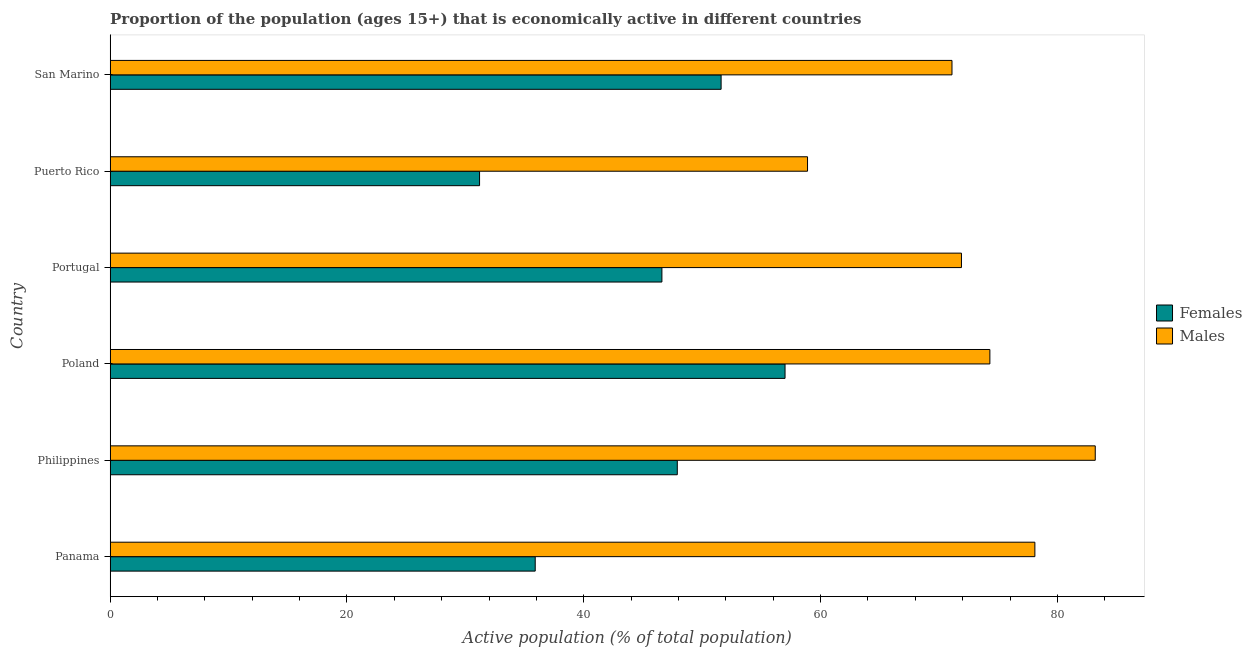Are the number of bars per tick equal to the number of legend labels?
Make the answer very short. Yes. How many bars are there on the 3rd tick from the top?
Your response must be concise. 2. How many bars are there on the 3rd tick from the bottom?
Provide a succinct answer. 2. What is the label of the 1st group of bars from the top?
Keep it short and to the point. San Marino. In how many cases, is the number of bars for a given country not equal to the number of legend labels?
Your answer should be compact. 0. What is the percentage of economically active male population in Portugal?
Keep it short and to the point. 71.9. Across all countries, what is the maximum percentage of economically active female population?
Offer a very short reply. 57. Across all countries, what is the minimum percentage of economically active female population?
Provide a short and direct response. 31.2. In which country was the percentage of economically active male population maximum?
Your answer should be very brief. Philippines. In which country was the percentage of economically active female population minimum?
Your response must be concise. Puerto Rico. What is the total percentage of economically active female population in the graph?
Keep it short and to the point. 270.2. What is the difference between the percentage of economically active male population in Poland and that in Puerto Rico?
Your response must be concise. 15.4. What is the difference between the percentage of economically active male population in San Marino and the percentage of economically active female population in Poland?
Your answer should be compact. 14.1. What is the average percentage of economically active male population per country?
Provide a succinct answer. 72.92. What is the difference between the percentage of economically active female population and percentage of economically active male population in Puerto Rico?
Give a very brief answer. -27.7. In how many countries, is the percentage of economically active male population greater than 60 %?
Your answer should be compact. 5. What is the ratio of the percentage of economically active male population in Panama to that in Puerto Rico?
Ensure brevity in your answer.  1.33. Is the difference between the percentage of economically active female population in Portugal and San Marino greater than the difference between the percentage of economically active male population in Portugal and San Marino?
Give a very brief answer. No. What is the difference between the highest and the second highest percentage of economically active female population?
Offer a very short reply. 5.4. What is the difference between the highest and the lowest percentage of economically active female population?
Provide a short and direct response. 25.8. In how many countries, is the percentage of economically active female population greater than the average percentage of economically active female population taken over all countries?
Give a very brief answer. 4. Is the sum of the percentage of economically active female population in Poland and Portugal greater than the maximum percentage of economically active male population across all countries?
Ensure brevity in your answer.  Yes. What does the 1st bar from the top in San Marino represents?
Offer a terse response. Males. What does the 2nd bar from the bottom in Poland represents?
Your answer should be very brief. Males. How many bars are there?
Ensure brevity in your answer.  12. What is the difference between two consecutive major ticks on the X-axis?
Give a very brief answer. 20. Are the values on the major ticks of X-axis written in scientific E-notation?
Provide a short and direct response. No. Does the graph contain any zero values?
Your answer should be very brief. No. Where does the legend appear in the graph?
Your answer should be compact. Center right. How many legend labels are there?
Offer a terse response. 2. How are the legend labels stacked?
Offer a very short reply. Vertical. What is the title of the graph?
Your answer should be very brief. Proportion of the population (ages 15+) that is economically active in different countries. What is the label or title of the X-axis?
Provide a succinct answer. Active population (% of total population). What is the label or title of the Y-axis?
Your answer should be very brief. Country. What is the Active population (% of total population) in Females in Panama?
Offer a terse response. 35.9. What is the Active population (% of total population) of Males in Panama?
Offer a terse response. 78.1. What is the Active population (% of total population) in Females in Philippines?
Provide a short and direct response. 47.9. What is the Active population (% of total population) in Males in Philippines?
Provide a succinct answer. 83.2. What is the Active population (% of total population) of Females in Poland?
Make the answer very short. 57. What is the Active population (% of total population) of Males in Poland?
Ensure brevity in your answer.  74.3. What is the Active population (% of total population) in Females in Portugal?
Offer a very short reply. 46.6. What is the Active population (% of total population) in Males in Portugal?
Ensure brevity in your answer.  71.9. What is the Active population (% of total population) of Females in Puerto Rico?
Provide a short and direct response. 31.2. What is the Active population (% of total population) in Males in Puerto Rico?
Your answer should be compact. 58.9. What is the Active population (% of total population) in Females in San Marino?
Ensure brevity in your answer.  51.6. What is the Active population (% of total population) in Males in San Marino?
Provide a succinct answer. 71.1. Across all countries, what is the maximum Active population (% of total population) in Males?
Provide a short and direct response. 83.2. Across all countries, what is the minimum Active population (% of total population) of Females?
Provide a short and direct response. 31.2. Across all countries, what is the minimum Active population (% of total population) of Males?
Provide a succinct answer. 58.9. What is the total Active population (% of total population) of Females in the graph?
Keep it short and to the point. 270.2. What is the total Active population (% of total population) in Males in the graph?
Your response must be concise. 437.5. What is the difference between the Active population (% of total population) of Males in Panama and that in Philippines?
Ensure brevity in your answer.  -5.1. What is the difference between the Active population (% of total population) of Females in Panama and that in Poland?
Provide a short and direct response. -21.1. What is the difference between the Active population (% of total population) of Males in Panama and that in Poland?
Provide a short and direct response. 3.8. What is the difference between the Active population (% of total population) of Females in Panama and that in Portugal?
Keep it short and to the point. -10.7. What is the difference between the Active population (% of total population) of Males in Panama and that in Puerto Rico?
Your answer should be compact. 19.2. What is the difference between the Active population (% of total population) of Females in Panama and that in San Marino?
Your answer should be compact. -15.7. What is the difference between the Active population (% of total population) in Males in Panama and that in San Marino?
Make the answer very short. 7. What is the difference between the Active population (% of total population) of Females in Philippines and that in Portugal?
Your answer should be compact. 1.3. What is the difference between the Active population (% of total population) of Males in Philippines and that in Puerto Rico?
Your answer should be very brief. 24.3. What is the difference between the Active population (% of total population) of Females in Philippines and that in San Marino?
Make the answer very short. -3.7. What is the difference between the Active population (% of total population) in Males in Philippines and that in San Marino?
Give a very brief answer. 12.1. What is the difference between the Active population (% of total population) in Females in Poland and that in Portugal?
Make the answer very short. 10.4. What is the difference between the Active population (% of total population) of Males in Poland and that in Portugal?
Ensure brevity in your answer.  2.4. What is the difference between the Active population (% of total population) in Females in Poland and that in Puerto Rico?
Keep it short and to the point. 25.8. What is the difference between the Active population (% of total population) of Males in Poland and that in Puerto Rico?
Offer a very short reply. 15.4. What is the difference between the Active population (% of total population) of Males in Poland and that in San Marino?
Your response must be concise. 3.2. What is the difference between the Active population (% of total population) in Females in Portugal and that in Puerto Rico?
Ensure brevity in your answer.  15.4. What is the difference between the Active population (% of total population) of Males in Portugal and that in Puerto Rico?
Your answer should be compact. 13. What is the difference between the Active population (% of total population) of Males in Portugal and that in San Marino?
Ensure brevity in your answer.  0.8. What is the difference between the Active population (% of total population) of Females in Puerto Rico and that in San Marino?
Your answer should be compact. -20.4. What is the difference between the Active population (% of total population) in Males in Puerto Rico and that in San Marino?
Provide a short and direct response. -12.2. What is the difference between the Active population (% of total population) of Females in Panama and the Active population (% of total population) of Males in Philippines?
Offer a very short reply. -47.3. What is the difference between the Active population (% of total population) in Females in Panama and the Active population (% of total population) in Males in Poland?
Ensure brevity in your answer.  -38.4. What is the difference between the Active population (% of total population) in Females in Panama and the Active population (% of total population) in Males in Portugal?
Offer a terse response. -36. What is the difference between the Active population (% of total population) in Females in Panama and the Active population (% of total population) in Males in San Marino?
Make the answer very short. -35.2. What is the difference between the Active population (% of total population) of Females in Philippines and the Active population (% of total population) of Males in Poland?
Your answer should be very brief. -26.4. What is the difference between the Active population (% of total population) in Females in Philippines and the Active population (% of total population) in Males in Portugal?
Ensure brevity in your answer.  -24. What is the difference between the Active population (% of total population) of Females in Philippines and the Active population (% of total population) of Males in Puerto Rico?
Your answer should be compact. -11. What is the difference between the Active population (% of total population) of Females in Philippines and the Active population (% of total population) of Males in San Marino?
Provide a short and direct response. -23.2. What is the difference between the Active population (% of total population) of Females in Poland and the Active population (% of total population) of Males in Portugal?
Offer a very short reply. -14.9. What is the difference between the Active population (% of total population) in Females in Poland and the Active population (% of total population) in Males in Puerto Rico?
Give a very brief answer. -1.9. What is the difference between the Active population (% of total population) in Females in Poland and the Active population (% of total population) in Males in San Marino?
Keep it short and to the point. -14.1. What is the difference between the Active population (% of total population) in Females in Portugal and the Active population (% of total population) in Males in San Marino?
Offer a very short reply. -24.5. What is the difference between the Active population (% of total population) of Females in Puerto Rico and the Active population (% of total population) of Males in San Marino?
Your answer should be compact. -39.9. What is the average Active population (% of total population) in Females per country?
Provide a succinct answer. 45.03. What is the average Active population (% of total population) of Males per country?
Your answer should be compact. 72.92. What is the difference between the Active population (% of total population) in Females and Active population (% of total population) in Males in Panama?
Ensure brevity in your answer.  -42.2. What is the difference between the Active population (% of total population) of Females and Active population (% of total population) of Males in Philippines?
Offer a very short reply. -35.3. What is the difference between the Active population (% of total population) in Females and Active population (% of total population) in Males in Poland?
Give a very brief answer. -17.3. What is the difference between the Active population (% of total population) of Females and Active population (% of total population) of Males in Portugal?
Provide a short and direct response. -25.3. What is the difference between the Active population (% of total population) of Females and Active population (% of total population) of Males in Puerto Rico?
Offer a very short reply. -27.7. What is the difference between the Active population (% of total population) in Females and Active population (% of total population) in Males in San Marino?
Provide a short and direct response. -19.5. What is the ratio of the Active population (% of total population) in Females in Panama to that in Philippines?
Ensure brevity in your answer.  0.75. What is the ratio of the Active population (% of total population) in Males in Panama to that in Philippines?
Provide a short and direct response. 0.94. What is the ratio of the Active population (% of total population) of Females in Panama to that in Poland?
Your response must be concise. 0.63. What is the ratio of the Active population (% of total population) in Males in Panama to that in Poland?
Provide a short and direct response. 1.05. What is the ratio of the Active population (% of total population) of Females in Panama to that in Portugal?
Your answer should be very brief. 0.77. What is the ratio of the Active population (% of total population) in Males in Panama to that in Portugal?
Your answer should be very brief. 1.09. What is the ratio of the Active population (% of total population) of Females in Panama to that in Puerto Rico?
Keep it short and to the point. 1.15. What is the ratio of the Active population (% of total population) in Males in Panama to that in Puerto Rico?
Provide a succinct answer. 1.33. What is the ratio of the Active population (% of total population) of Females in Panama to that in San Marino?
Give a very brief answer. 0.7. What is the ratio of the Active population (% of total population) of Males in Panama to that in San Marino?
Keep it short and to the point. 1.1. What is the ratio of the Active population (% of total population) of Females in Philippines to that in Poland?
Give a very brief answer. 0.84. What is the ratio of the Active population (% of total population) in Males in Philippines to that in Poland?
Offer a terse response. 1.12. What is the ratio of the Active population (% of total population) of Females in Philippines to that in Portugal?
Keep it short and to the point. 1.03. What is the ratio of the Active population (% of total population) in Males in Philippines to that in Portugal?
Your answer should be compact. 1.16. What is the ratio of the Active population (% of total population) of Females in Philippines to that in Puerto Rico?
Make the answer very short. 1.54. What is the ratio of the Active population (% of total population) of Males in Philippines to that in Puerto Rico?
Provide a succinct answer. 1.41. What is the ratio of the Active population (% of total population) of Females in Philippines to that in San Marino?
Keep it short and to the point. 0.93. What is the ratio of the Active population (% of total population) of Males in Philippines to that in San Marino?
Your answer should be compact. 1.17. What is the ratio of the Active population (% of total population) of Females in Poland to that in Portugal?
Give a very brief answer. 1.22. What is the ratio of the Active population (% of total population) in Males in Poland to that in Portugal?
Keep it short and to the point. 1.03. What is the ratio of the Active population (% of total population) in Females in Poland to that in Puerto Rico?
Your answer should be very brief. 1.83. What is the ratio of the Active population (% of total population) in Males in Poland to that in Puerto Rico?
Give a very brief answer. 1.26. What is the ratio of the Active population (% of total population) of Females in Poland to that in San Marino?
Your response must be concise. 1.1. What is the ratio of the Active population (% of total population) of Males in Poland to that in San Marino?
Your response must be concise. 1.04. What is the ratio of the Active population (% of total population) of Females in Portugal to that in Puerto Rico?
Offer a very short reply. 1.49. What is the ratio of the Active population (% of total population) of Males in Portugal to that in Puerto Rico?
Offer a terse response. 1.22. What is the ratio of the Active population (% of total population) in Females in Portugal to that in San Marino?
Your response must be concise. 0.9. What is the ratio of the Active population (% of total population) of Males in Portugal to that in San Marino?
Offer a very short reply. 1.01. What is the ratio of the Active population (% of total population) in Females in Puerto Rico to that in San Marino?
Your response must be concise. 0.6. What is the ratio of the Active population (% of total population) in Males in Puerto Rico to that in San Marino?
Your answer should be very brief. 0.83. What is the difference between the highest and the lowest Active population (% of total population) of Females?
Ensure brevity in your answer.  25.8. What is the difference between the highest and the lowest Active population (% of total population) of Males?
Provide a short and direct response. 24.3. 